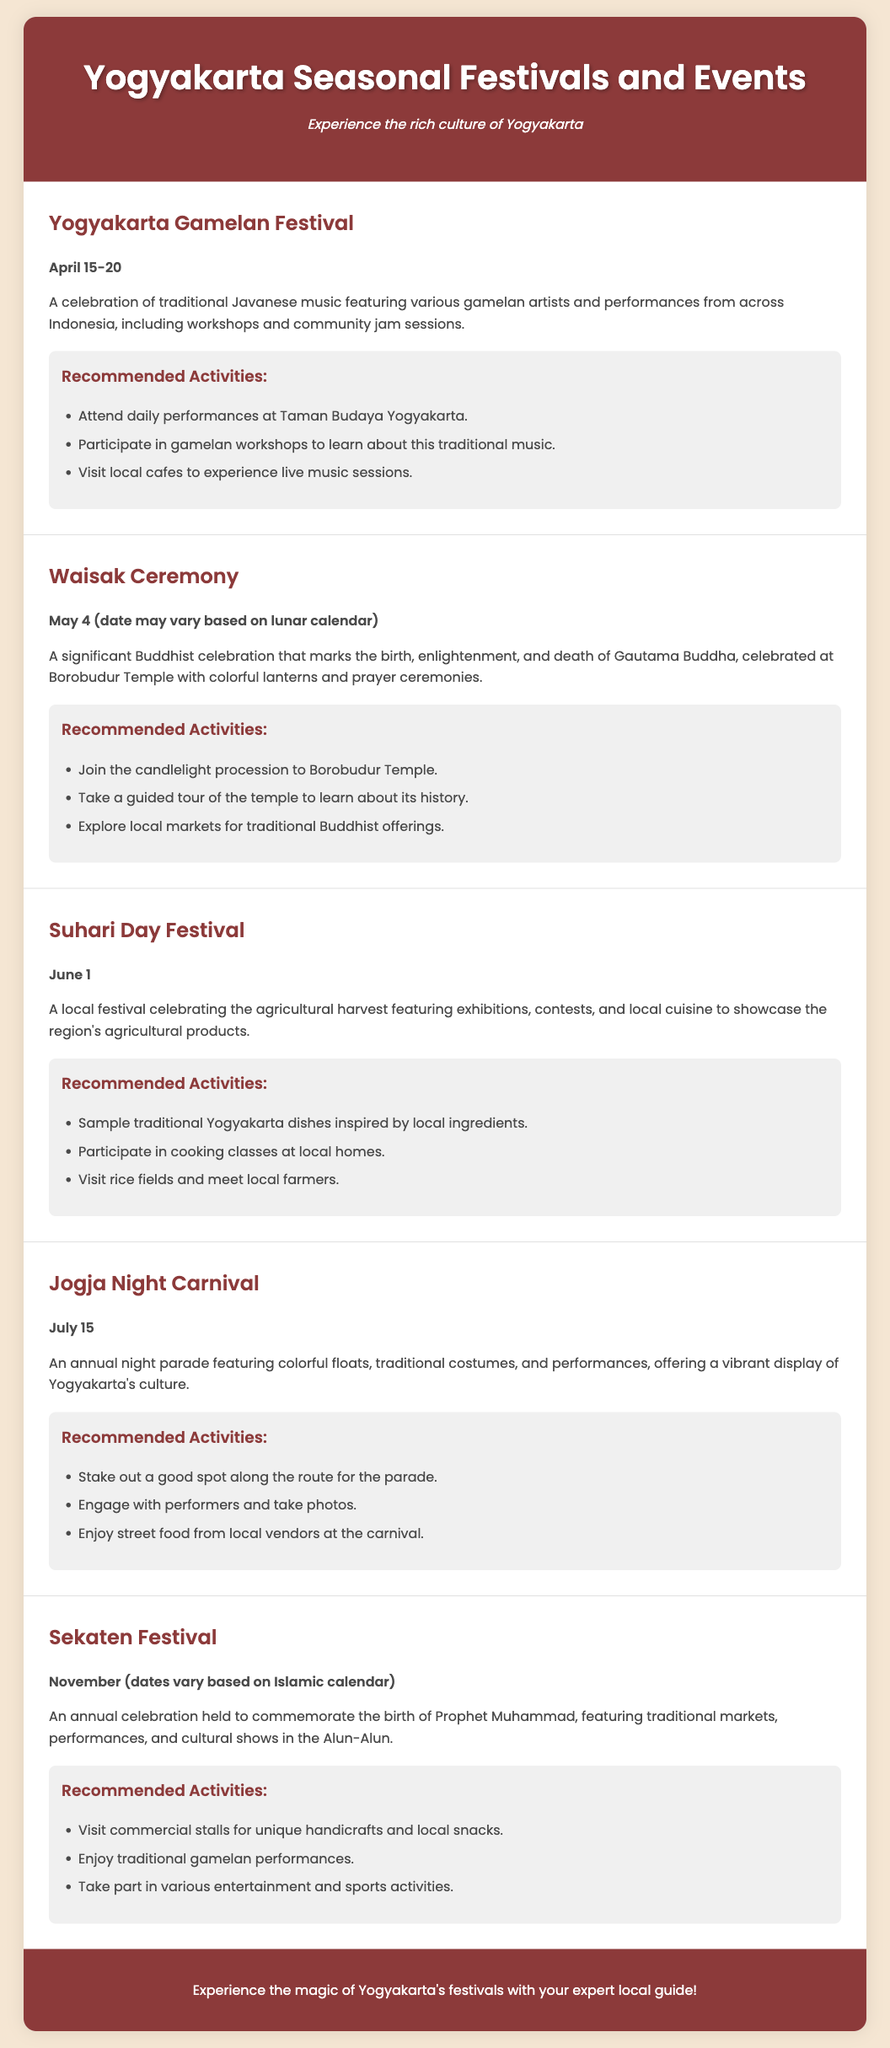What is the date of the Yogyakarta Gamelan Festival? The Yogyakarta Gamelan Festival takes place from April 15 to April 20.
Answer: April 15-20 What is celebrated during the Waisak Ceremony? The Waisak Ceremony marks the birth, enlightenment, and death of Gautama Buddha.
Answer: Birth, enlightenment, and death of Gautama Buddha What activities are recommended for the Suhari Day Festival? Recommended activities for the Suhari Day Festival include sampling traditional dishes and visiting rice fields.
Answer: Sample traditional Yogyakarta dishes, visit rice fields When is the Jogja Night Carnival held? The Jogja Night Carnival is held on July 15.
Answer: July 15 What event features a candlelight procession to Borobudur Temple? The event that features a candlelight procession is the Waisak Ceremony.
Answer: Waisak Ceremony What is a key feature of the Sekaten Festival? A key feature of the Sekaten Festival is traditional markets and cultural shows.
Answer: Traditional markets and cultural shows Which festival celebrates traditional Javanese music? The festival that celebrates traditional Javanese music is the Yogyakarta Gamelan Festival.
Answer: Yogyakarta Gamelan Festival What is the main theme of the Jogja Night Carnival? The main theme of the Jogja Night Carnival is a vibrant display of Yogyakarta's culture.
Answer: A vibrant display of Yogyakarta's culture 